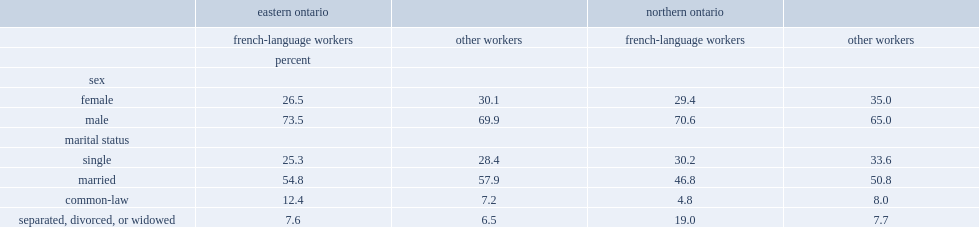Which group of workers has a higher proportion of men?other workers or french-language workers? French-language workers. What percent of french-language agricultural workers in northern ontario was married? 46.8. 